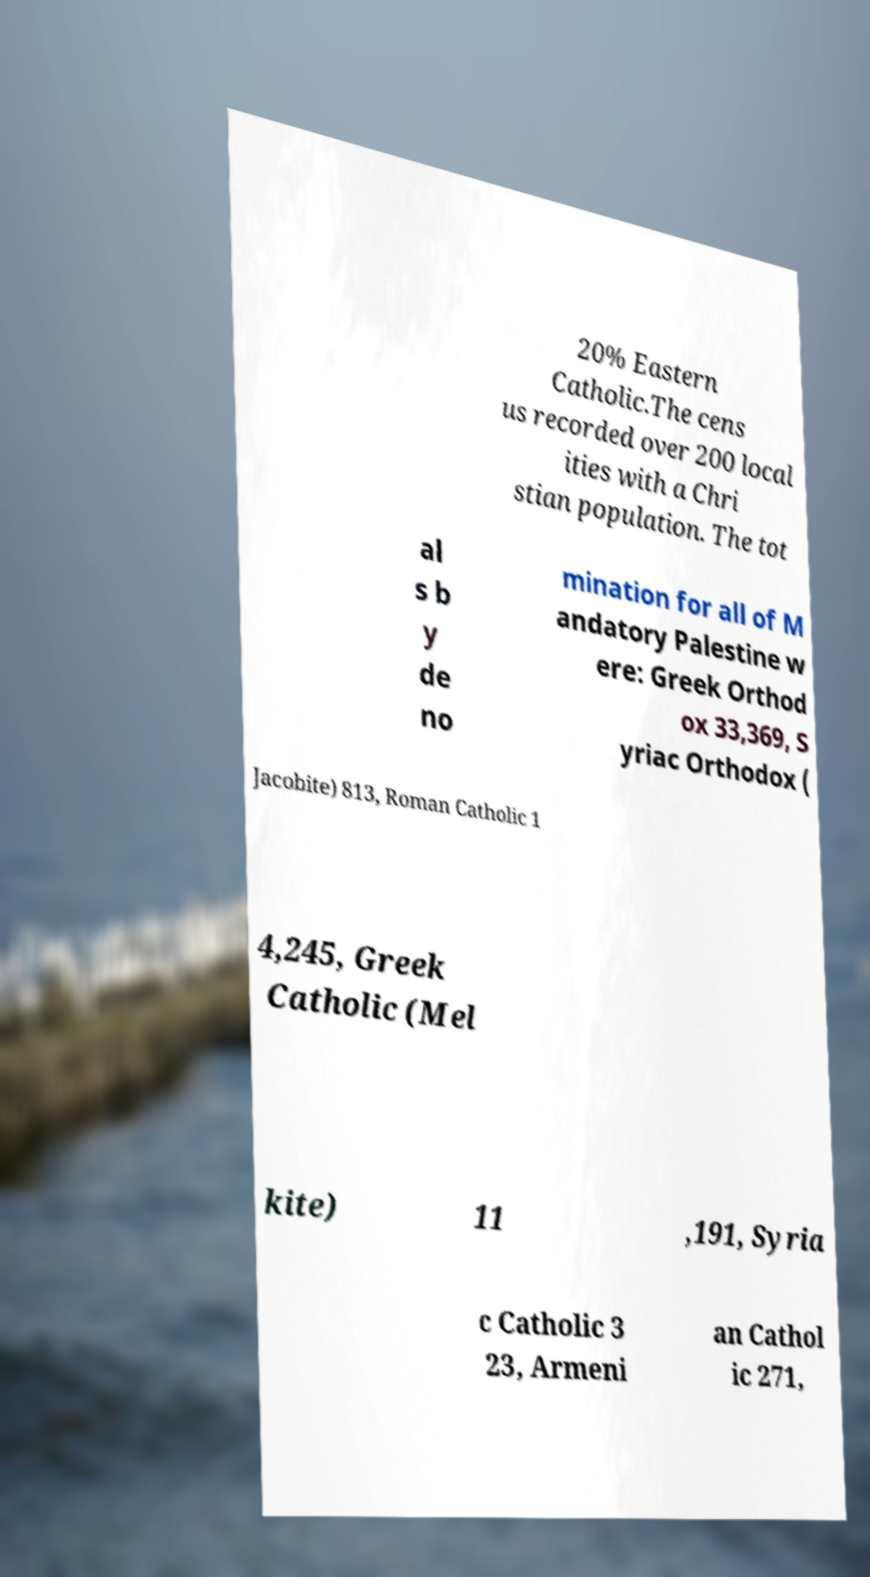Please read and relay the text visible in this image. What does it say? 20% Eastern Catholic.The cens us recorded over 200 local ities with a Chri stian population. The tot al s b y de no mination for all of M andatory Palestine w ere: Greek Orthod ox 33,369, S yriac Orthodox ( Jacobite) 813, Roman Catholic 1 4,245, Greek Catholic (Mel kite) 11 ,191, Syria c Catholic 3 23, Armeni an Cathol ic 271, 